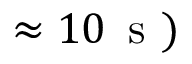<formula> <loc_0><loc_0><loc_500><loc_500>\approx 1 0 \, s )</formula> 